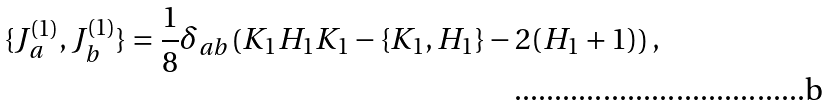<formula> <loc_0><loc_0><loc_500><loc_500>\{ J ^ { ( 1 ) } _ { a } , J ^ { ( 1 ) } _ { b } \} = \frac { 1 } { 8 } \delta _ { a b } \left ( K _ { 1 } H _ { 1 } K _ { 1 } - \{ K _ { 1 } , H _ { 1 } \} - 2 ( H _ { 1 } + 1 ) \right ) ,</formula> 